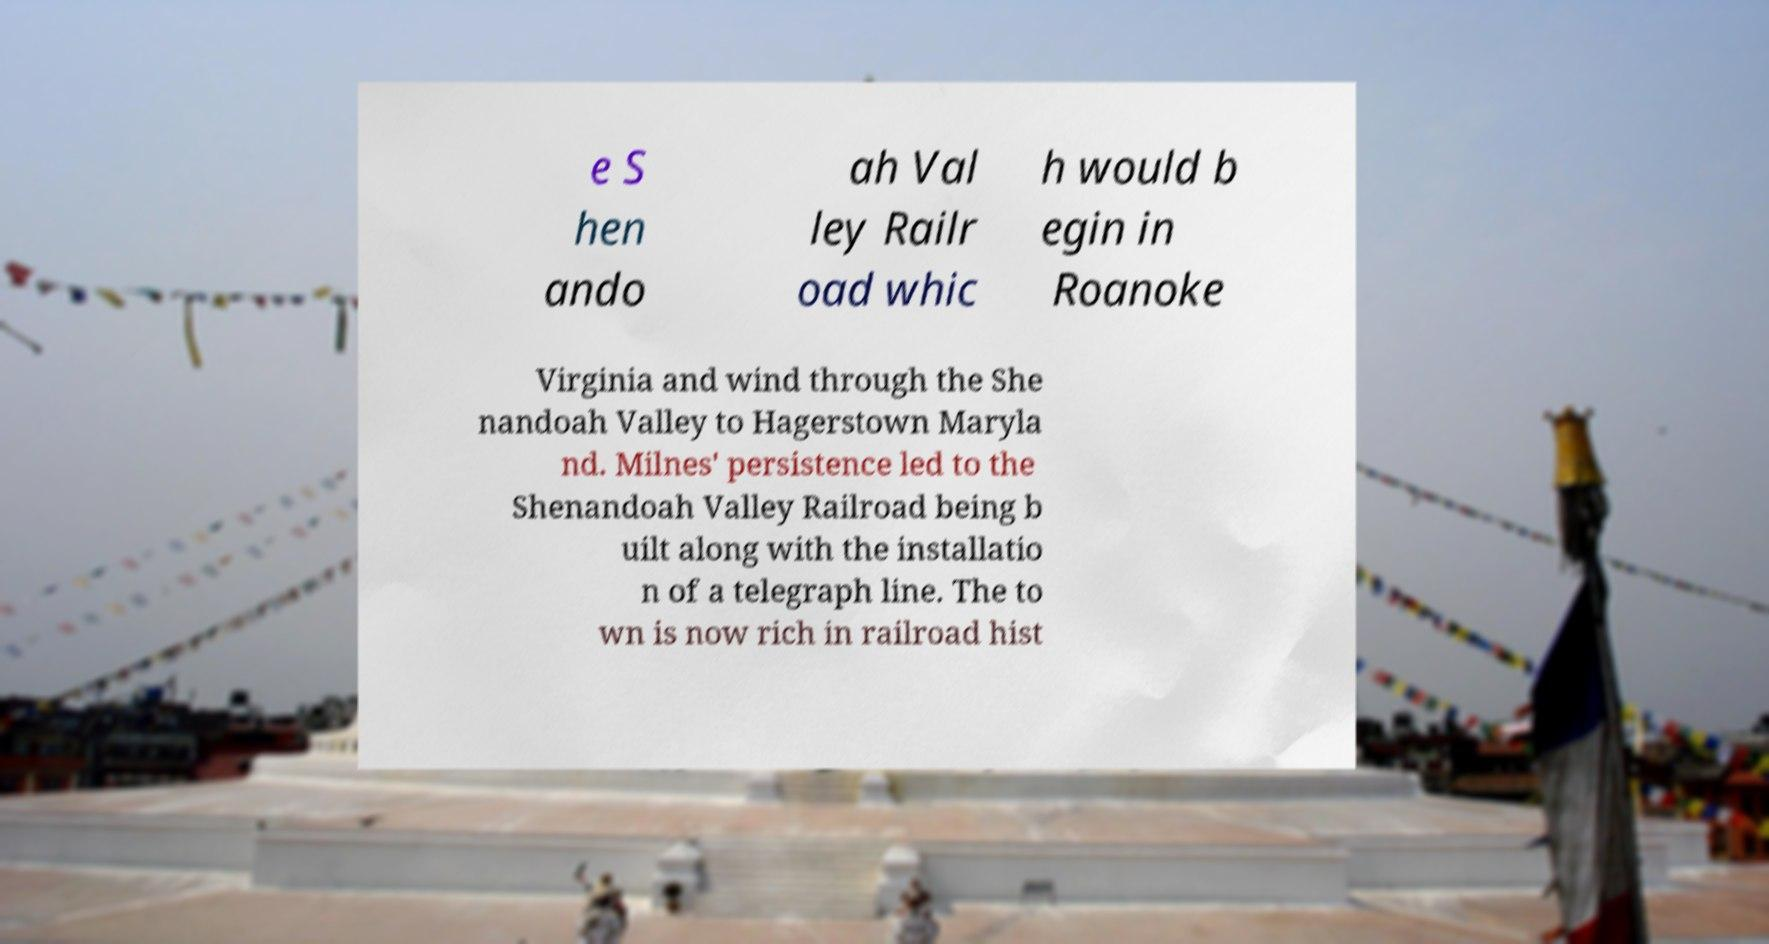Please read and relay the text visible in this image. What does it say? e S hen ando ah Val ley Railr oad whic h would b egin in Roanoke Virginia and wind through the She nandoah Valley to Hagerstown Maryla nd. Milnes' persistence led to the Shenandoah Valley Railroad being b uilt along with the installatio n of a telegraph line. The to wn is now rich in railroad hist 